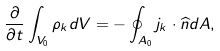<formula> <loc_0><loc_0><loc_500><loc_500>\frac { \partial } { \partial t } \int _ { V _ { 0 } } \rho _ { k } d V = - \oint _ { A _ { 0 } } { j } _ { k } \cdot \widehat { n } d A ,</formula> 